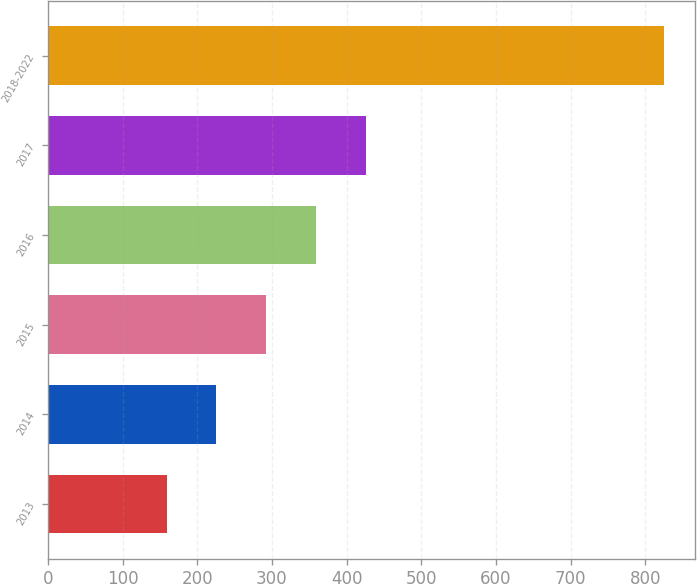Convert chart to OTSL. <chart><loc_0><loc_0><loc_500><loc_500><bar_chart><fcel>2013<fcel>2014<fcel>2015<fcel>2016<fcel>2017<fcel>2018-2022<nl><fcel>159<fcel>225.6<fcel>292.2<fcel>358.8<fcel>425.4<fcel>825<nl></chart> 